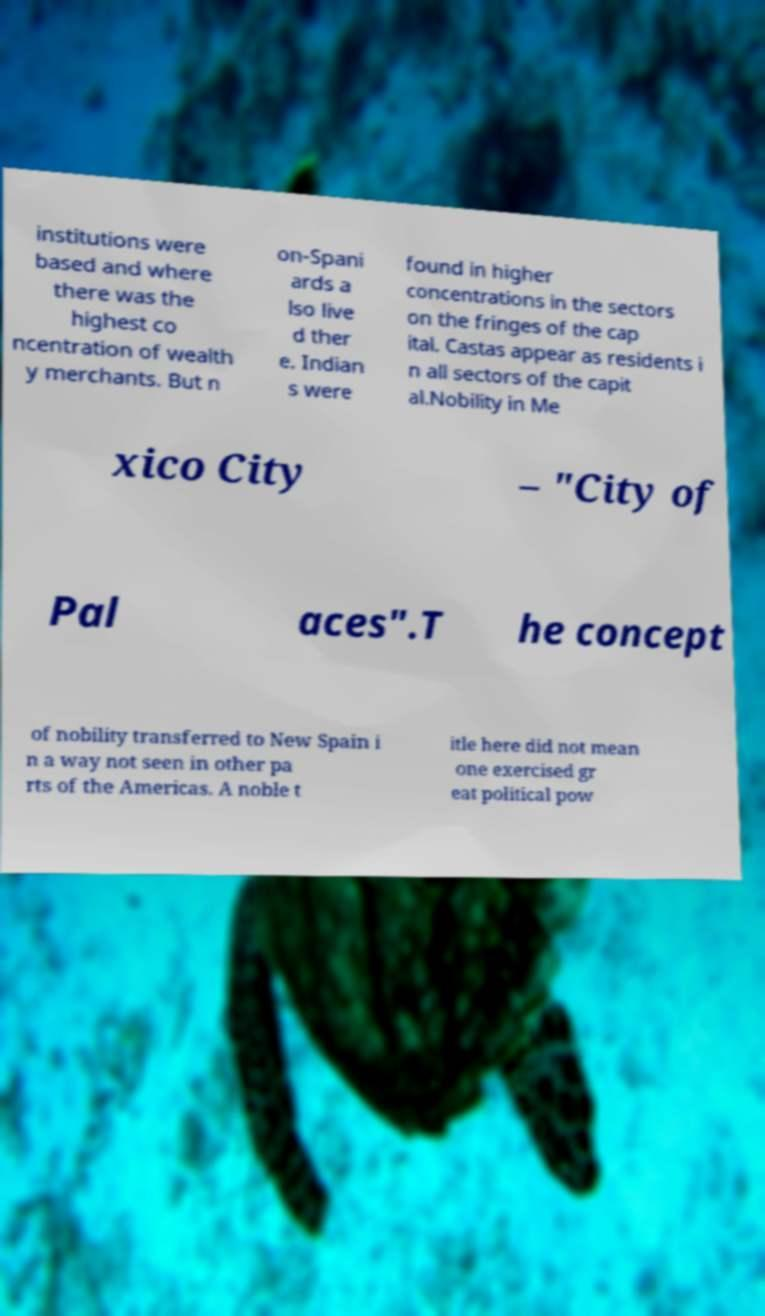Please identify and transcribe the text found in this image. institutions were based and where there was the highest co ncentration of wealth y merchants. But n on-Spani ards a lso live d ther e. Indian s were found in higher concentrations in the sectors on the fringes of the cap ital. Castas appear as residents i n all sectors of the capit al.Nobility in Me xico City – "City of Pal aces".T he concept of nobility transferred to New Spain i n a way not seen in other pa rts of the Americas. A noble t itle here did not mean one exercised gr eat political pow 